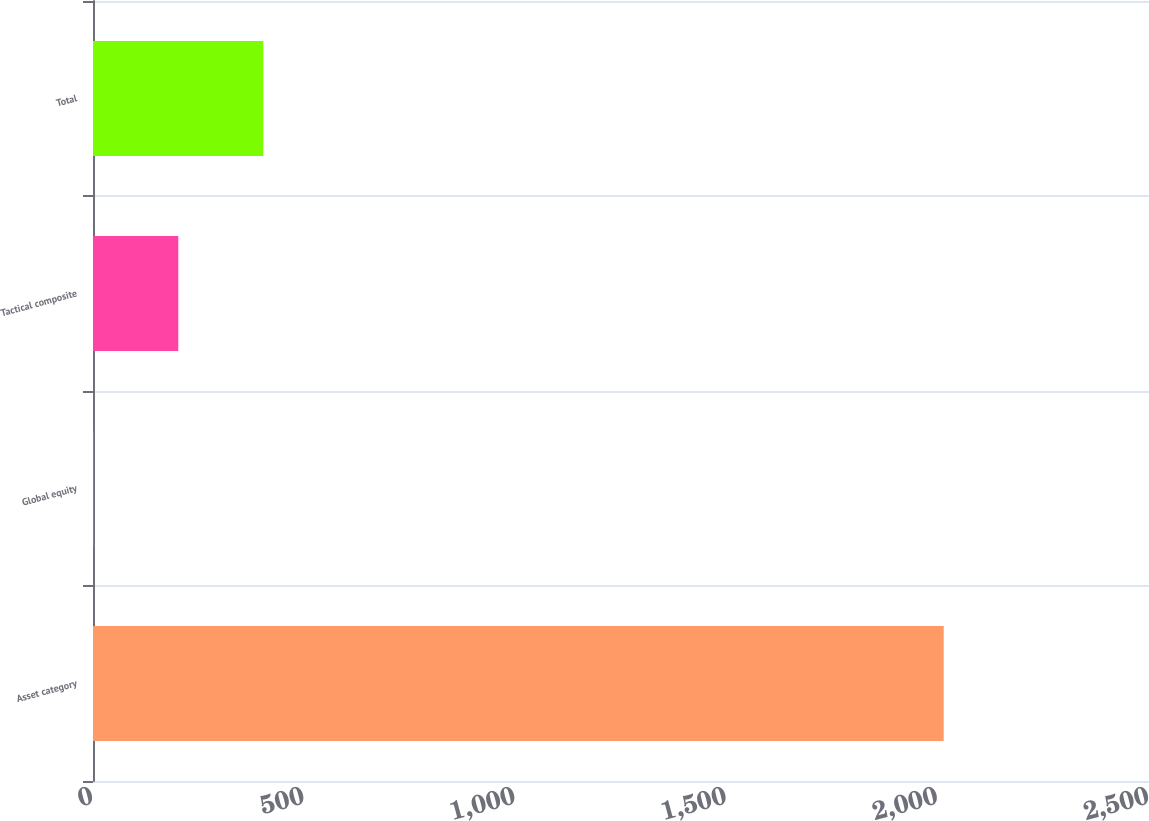<chart> <loc_0><loc_0><loc_500><loc_500><bar_chart><fcel>Asset category<fcel>Global equity<fcel>Tactical composite<fcel>Total<nl><fcel>2014<fcel>0.58<fcel>201.92<fcel>403.26<nl></chart> 